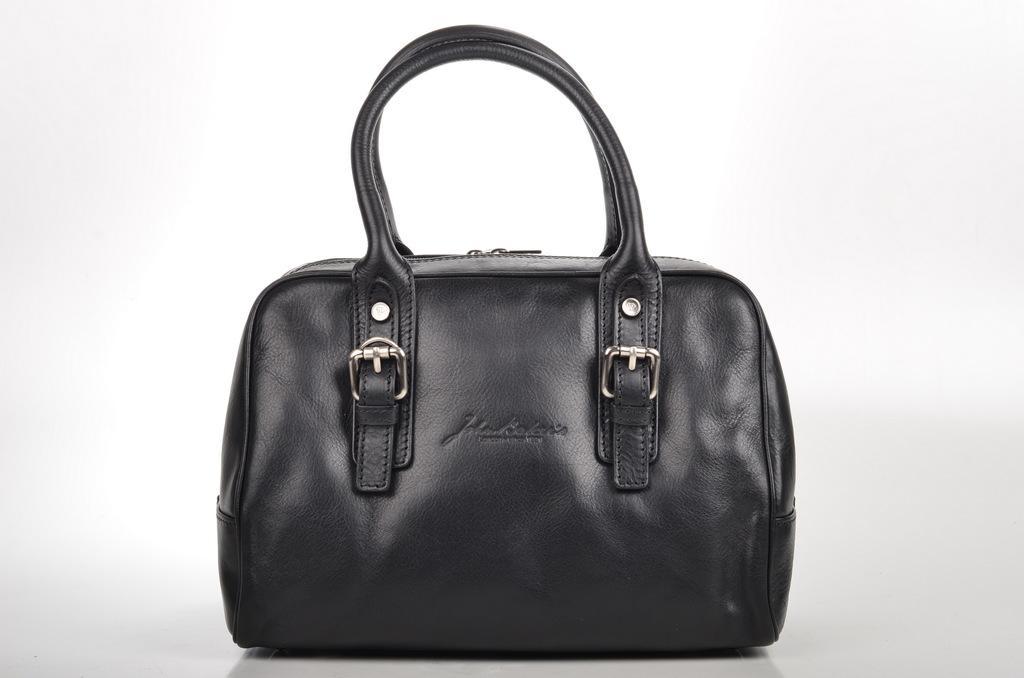Please provide a concise description of this image. In the image we can see there is a black bag. 